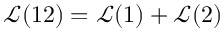Convert formula to latex. <formula><loc_0><loc_0><loc_500><loc_500>\mathcal { L } ( 1 2 ) = \mathcal { L } ( 1 ) + \mathcal { L } ( 2 )</formula> 